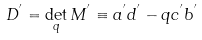<formula> <loc_0><loc_0><loc_500><loc_500>D ^ { ^ { \prime } } = \det _ { q } M ^ { ^ { \prime } } \equiv a ^ { ^ { \prime } } d ^ { ^ { \prime } } - q c ^ { ^ { \prime } } b ^ { ^ { \prime } }</formula> 